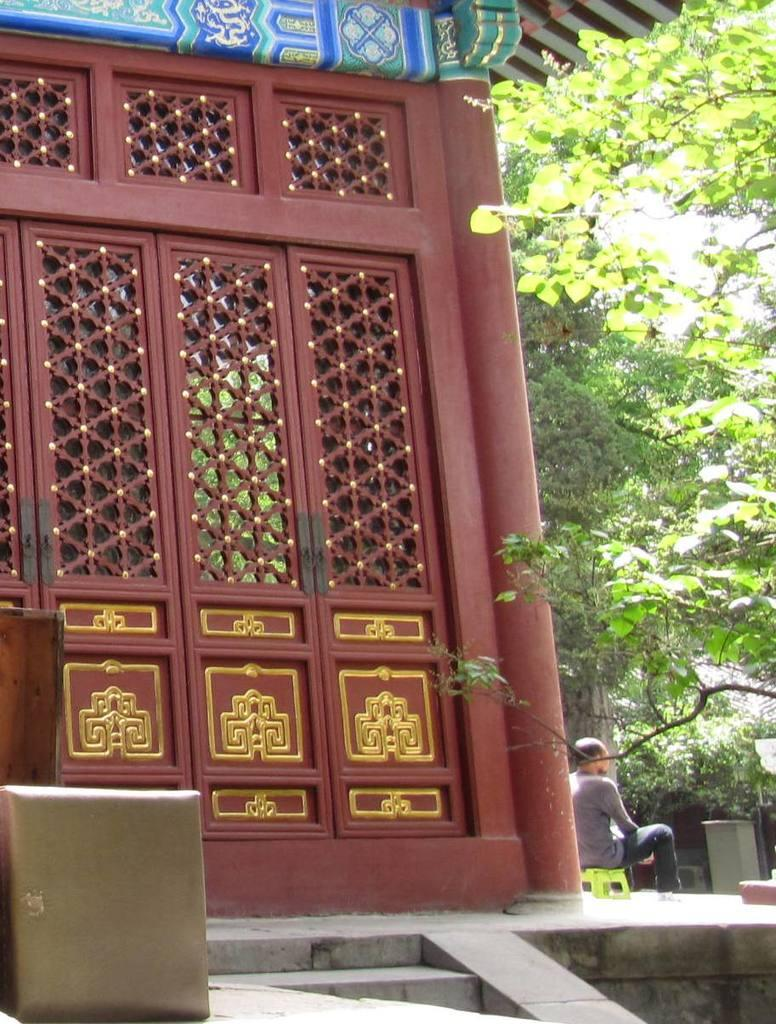What type of architectural feature can be seen in the image? There are doors in the image. What is located on the left side of the image? There are objects on the left side of the image. What is the person in the image doing? There is a person sitting on a stool in the image. What type of natural scenery is visible on the right side of the image? There are trees on the right side of the image. What type of knee surgery is being performed in the image? There is no knee surgery or any reference to a knee in the image. 